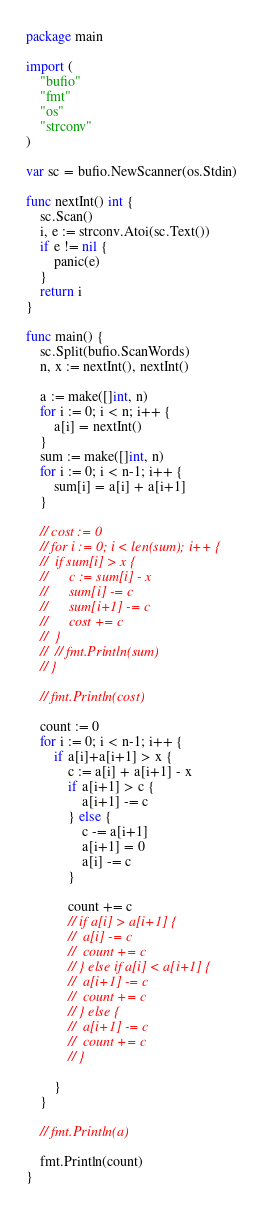<code> <loc_0><loc_0><loc_500><loc_500><_Go_>package main

import (
	"bufio"
	"fmt"
	"os"
	"strconv"
)

var sc = bufio.NewScanner(os.Stdin)

func nextInt() int {
	sc.Scan()
	i, e := strconv.Atoi(sc.Text())
	if e != nil {
		panic(e)
	}
	return i
}

func main() {
	sc.Split(bufio.ScanWords)
	n, x := nextInt(), nextInt()

	a := make([]int, n)
	for i := 0; i < n; i++ {
		a[i] = nextInt()
	}
	sum := make([]int, n)
	for i := 0; i < n-1; i++ {
		sum[i] = a[i] + a[i+1]
	}

	// cost := 0
	// for i := 0; i < len(sum); i++ {
	// 	if sum[i] > x {
	// 		c := sum[i] - x
	// 		sum[i] -= c
	// 		sum[i+1] -= c
	// 		cost += c
	// 	}
	// 	// fmt.Println(sum)
	// }

	// fmt.Println(cost)

	count := 0
	for i := 0; i < n-1; i++ {
		if a[i]+a[i+1] > x {
			c := a[i] + a[i+1] - x
			if a[i+1] > c {
				a[i+1] -= c
			} else {
				c -= a[i+1]
				a[i+1] = 0
				a[i] -= c
			}

			count += c
			// if a[i] > a[i+1] {
			// 	a[i] -= c
			// 	count += c
			// } else if a[i] < a[i+1] {
			// 	a[i+1] -= c
			// 	count += c
			// } else {
			// 	a[i+1] -= c
			// 	count += c
			// }

		}
	}

	// fmt.Println(a)

	fmt.Println(count)
}
</code> 